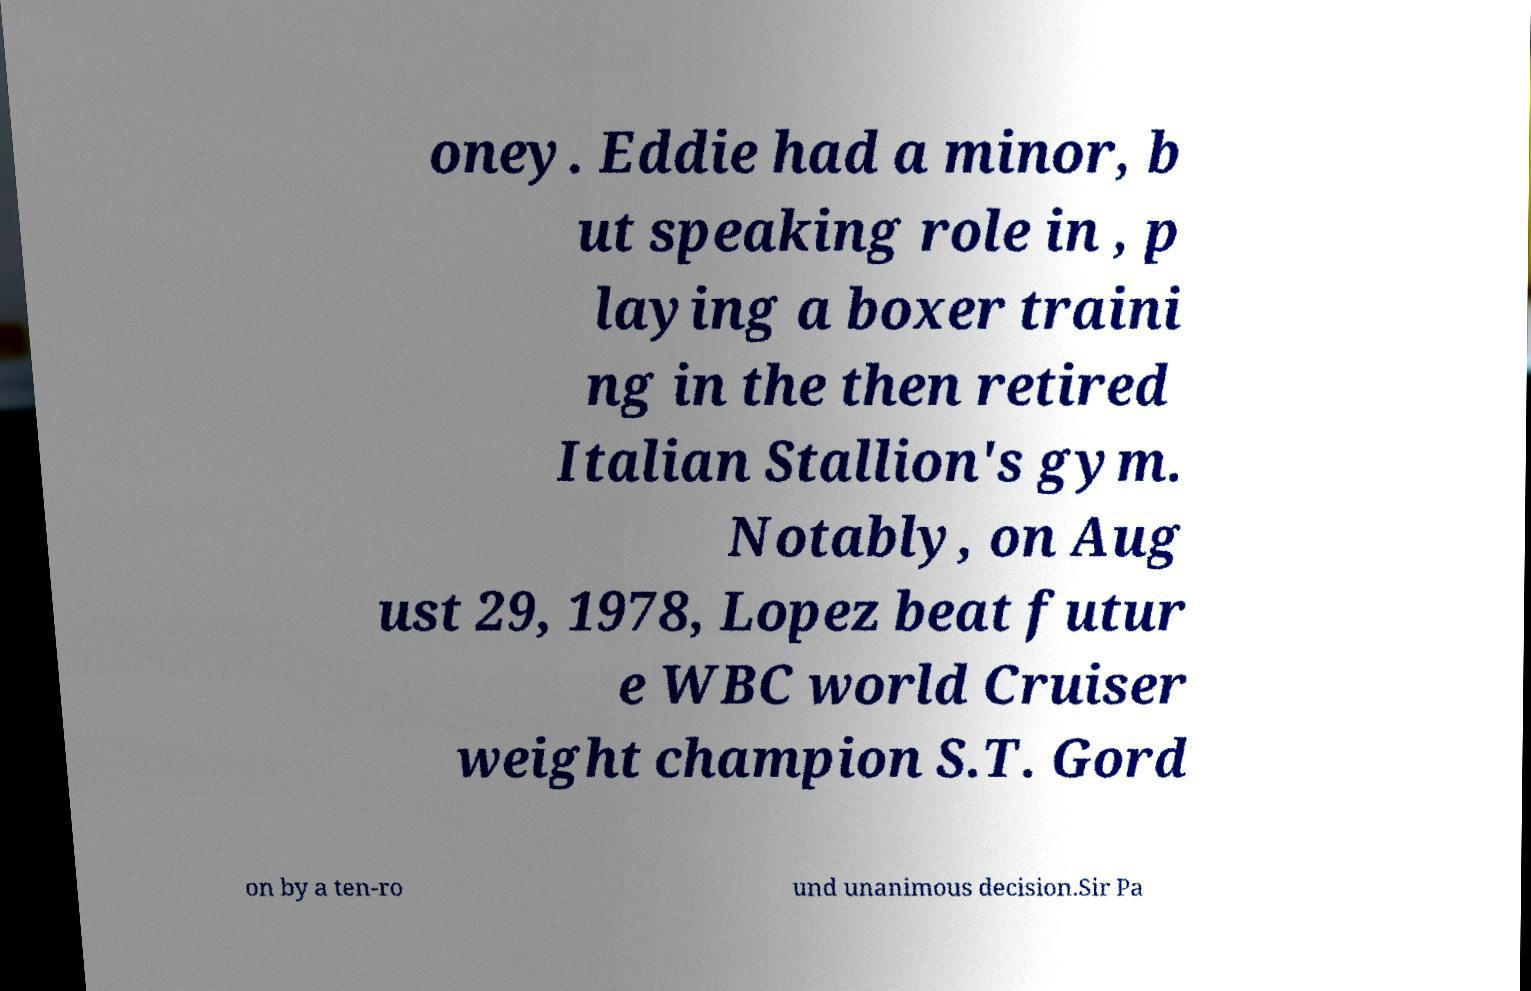Can you read and provide the text displayed in the image?This photo seems to have some interesting text. Can you extract and type it out for me? oney. Eddie had a minor, b ut speaking role in , p laying a boxer traini ng in the then retired Italian Stallion's gym. Notably, on Aug ust 29, 1978, Lopez beat futur e WBC world Cruiser weight champion S.T. Gord on by a ten-ro und unanimous decision.Sir Pa 